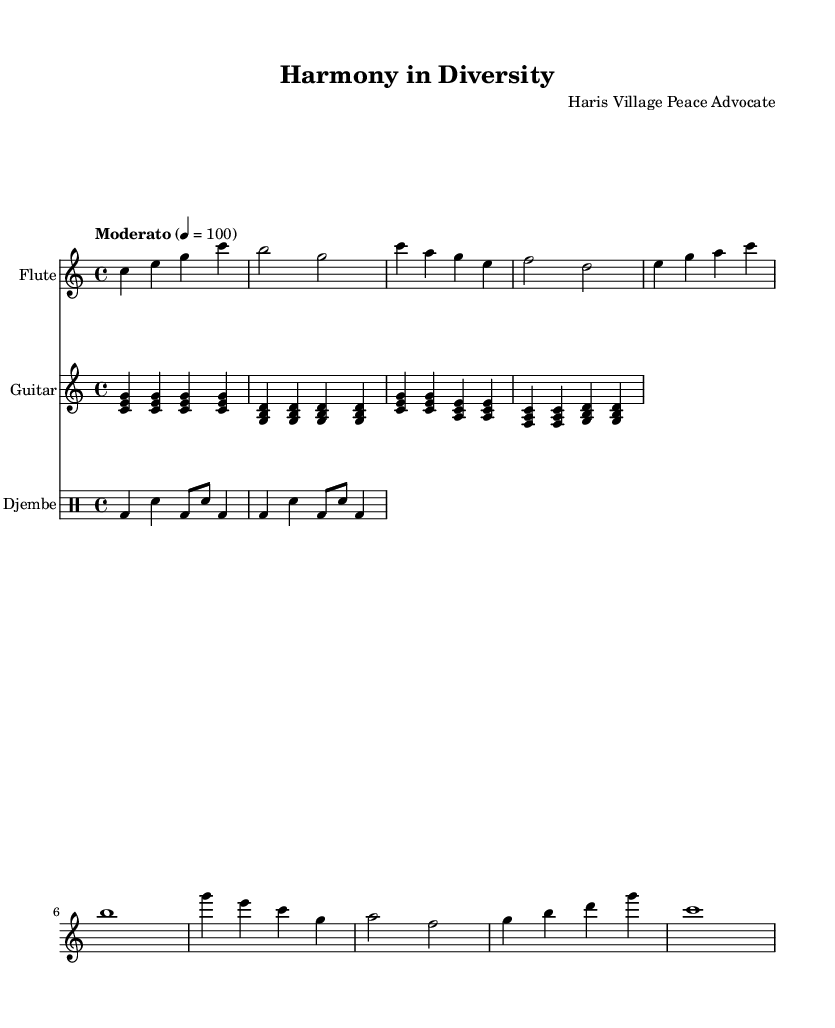What is the key signature of this music? The key signature is indicated at the beginning of the sheet music. In this case, it is C major, which has no sharps or flats.
Answer: C major What is the time signature of this piece? The time signature appears in the first measure of the sheet music. Here, it is 4/4, which means there are four beats in each measure and the quarter note gets one beat.
Answer: 4/4 What is the tempo marking for the music? The tempo marking is usually found at the beginning of the music. In this case, it is marked "Moderato" with a metronome marking of quarter note = 100.
Answer: Moderato How many measures are there in the flute part? By counting the measures in the flute staff, we find that there are a total of eight measures.
Answer: 8 What are the instruments used in this piece? The instruments are listed at the start of each staff and include Flute, Guitar, and Djembe, indicating a blend of melodic and rhythmic elements.
Answer: Flute, Guitar, Djembe Which instrument plays the longest note in the first line? Analyzing the first line of the flute part, we see that the longest note is a whole note (b1), which is held for an entire measure. This is the flute instrument.
Answer: Flute 